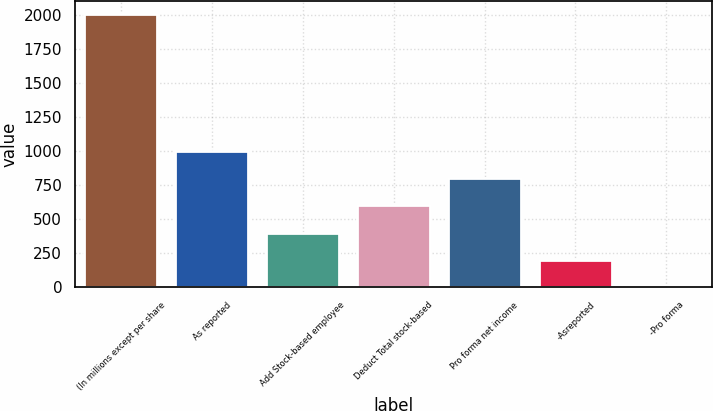<chart> <loc_0><loc_0><loc_500><loc_500><bar_chart><fcel>(In millions except per share<fcel>As reported<fcel>Add Stock-based employee<fcel>Deduct Total stock-based<fcel>Pro forma net income<fcel>-Asreported<fcel>-Pro forma<nl><fcel>2002<fcel>1001.83<fcel>401.71<fcel>601.75<fcel>801.79<fcel>201.67<fcel>1.63<nl></chart> 